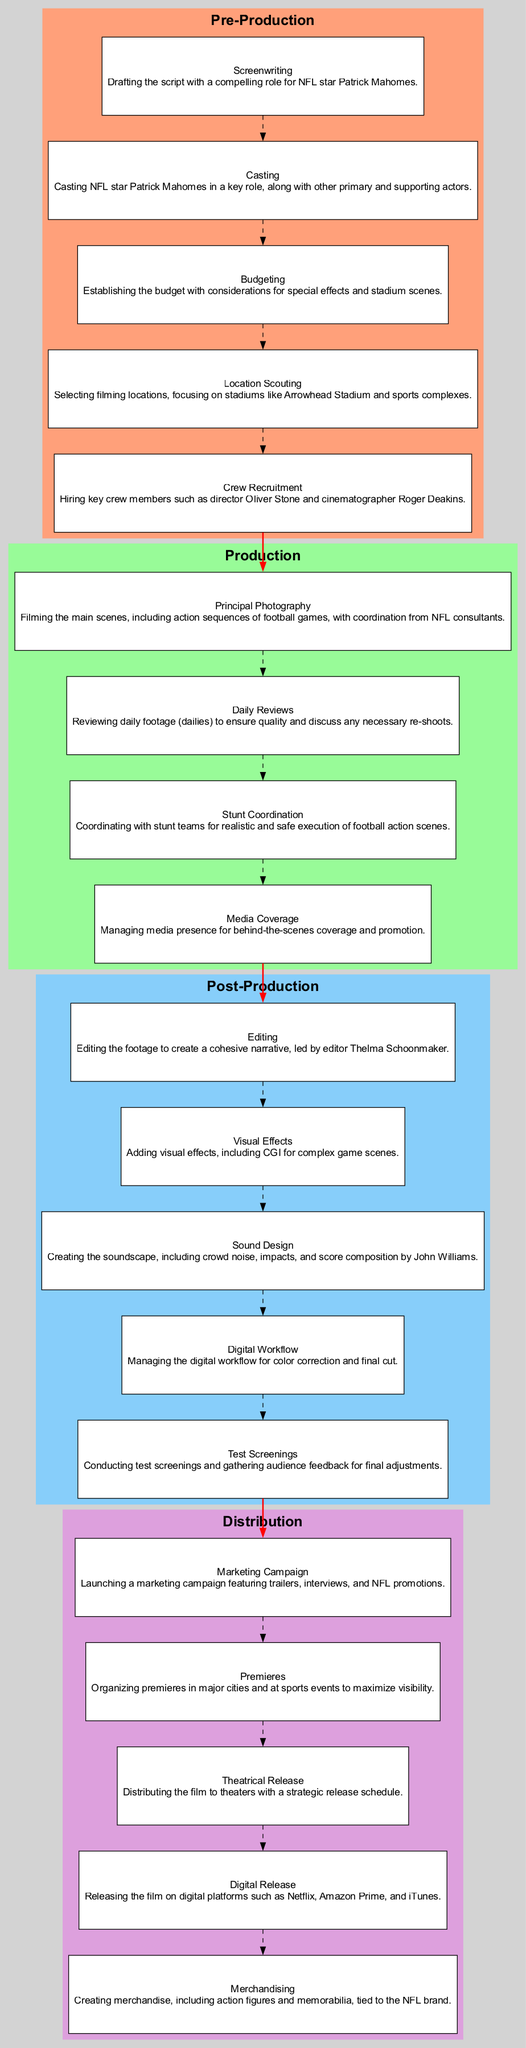What phase involves casting? The diagram indicates that the "Casting" task is part of the "Pre-Production" phase.
Answer: Pre-Production How many tasks are in the Production phase? By counting the elements listed under the "Production" phase, there are four tasks: Principal Photography, Daily Reviews, Stunt Coordination, and Media Coverage.
Answer: 4 Which task is managed by Thelma Schoonmaker? The diagram specifies that the "Editing" task is led by Thelma Schoonmaker in the Post-Production phase.
Answer: Editing What is the first task in the Post-Production phase? The "Editing" task is the first element listed under the "Post-Production" phase in the diagram.
Answer: Editing How does "Test Screenings" connect to "Editing"? In the diagram, "Editing" is a task in the Post-Production phase, and "Test Screenings" come after it; thus, the connection illustrates the workflow from editing to audience feedback.
Answer: Through Post-Production phase tasks List two tasks that involve media presence. The "Media Coverage" in the Production phase and the "Marketing Campaign" in the Distribution phase both involve media presence as their core elements.
Answer: Media Coverage, Marketing Campaign What is the last task before the film's digital release? The "Theatrical Release" task occurs directly before "Digital Release" in the Distribution phase of the diagram.
Answer: Theatrical Release Which task involves John Williams? The "Sound Design" task in the Post-Production phase specifies that the score composition is by John Williams.
Answer: Sound Design Identify the role of Oliver Stone in the diagram. Oliver Stone is mentioned as the director in the "Crew Recruitment" task under the Pre-Production phase.
Answer: Director 